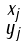Convert formula to latex. <formula><loc_0><loc_0><loc_500><loc_500>\begin{smallmatrix} x _ { j } \\ y _ { j } \end{smallmatrix}</formula> 